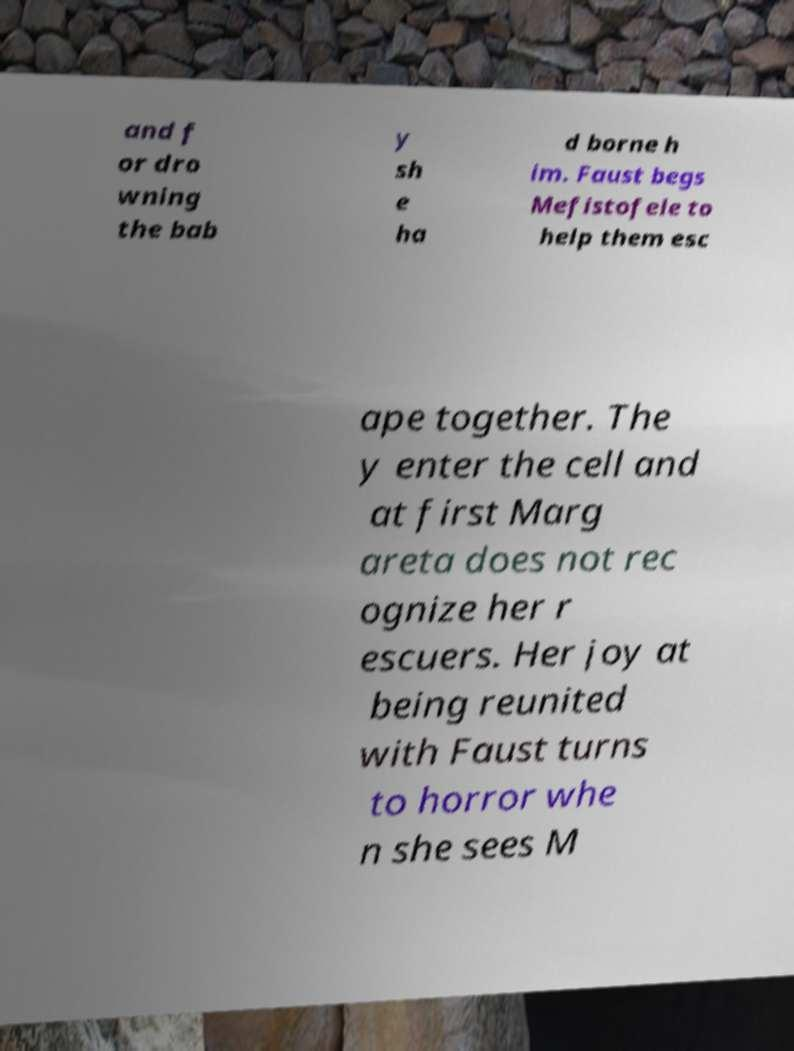Please identify and transcribe the text found in this image. and f or dro wning the bab y sh e ha d borne h im. Faust begs Mefistofele to help them esc ape together. The y enter the cell and at first Marg areta does not rec ognize her r escuers. Her joy at being reunited with Faust turns to horror whe n she sees M 